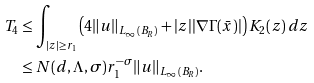<formula> <loc_0><loc_0><loc_500><loc_500>T _ { 4 } & \leq \int _ { | z | \geq r _ { 1 } } \left ( 4 \| u \| _ { L _ { \infty } ( B _ { R } ) } + | z | | \nabla \Gamma ( \bar { x } ) | \right ) K _ { 2 } ( z ) \, d z \\ & \leq N ( d , \Lambda , \sigma ) r _ { 1 } ^ { - \sigma } \| u \| _ { L _ { \infty } ( B _ { R } ) } .</formula> 